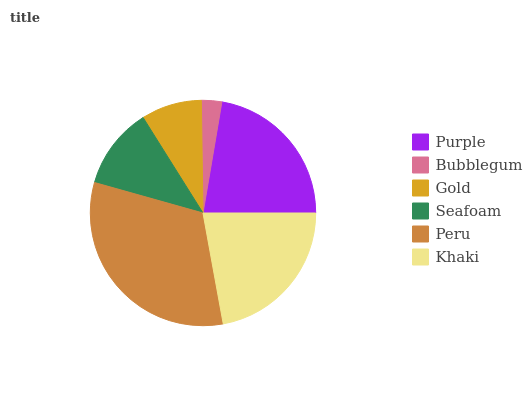Is Bubblegum the minimum?
Answer yes or no. Yes. Is Peru the maximum?
Answer yes or no. Yes. Is Gold the minimum?
Answer yes or no. No. Is Gold the maximum?
Answer yes or no. No. Is Gold greater than Bubblegum?
Answer yes or no. Yes. Is Bubblegum less than Gold?
Answer yes or no. Yes. Is Bubblegum greater than Gold?
Answer yes or no. No. Is Gold less than Bubblegum?
Answer yes or no. No. Is Khaki the high median?
Answer yes or no. Yes. Is Seafoam the low median?
Answer yes or no. Yes. Is Purple the high median?
Answer yes or no. No. Is Bubblegum the low median?
Answer yes or no. No. 